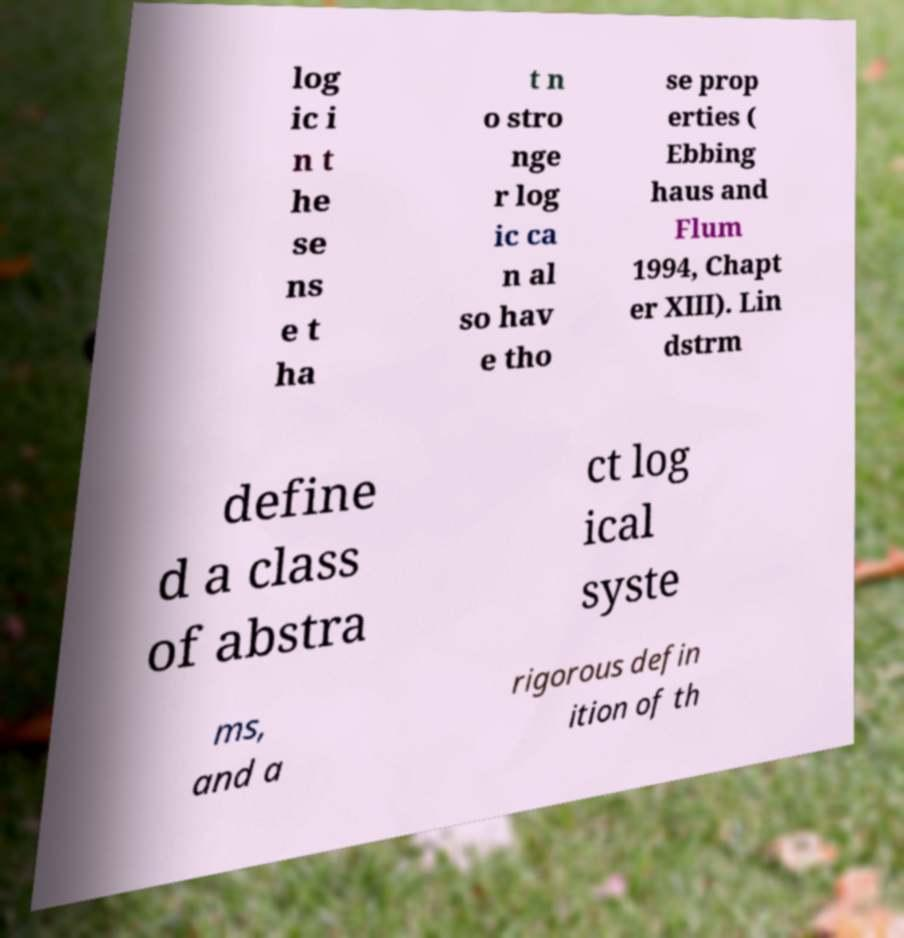Can you read and provide the text displayed in the image?This photo seems to have some interesting text. Can you extract and type it out for me? log ic i n t he se ns e t ha t n o stro nge r log ic ca n al so hav e tho se prop erties ( Ebbing haus and Flum 1994, Chapt er XIII). Lin dstrm define d a class of abstra ct log ical syste ms, and a rigorous defin ition of th 